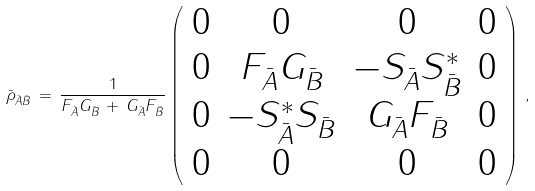Convert formula to latex. <formula><loc_0><loc_0><loc_500><loc_500>\bar { \rho } _ { \bar { A } \bar { B } } \, = \, \frac { 1 } { F _ { \bar { A } } G _ { \bar { B } } \, + \, G _ { \bar { A } } F _ { \bar { B } } } \left ( \begin{array} { c c c c } 0 & 0 & 0 & 0 \\ 0 & F _ { \bar { A } } G _ { \bar { B } } & - S _ { \bar { A } } S _ { \bar { B } } ^ { * } & 0 \\ 0 & - S _ { \bar { A } } ^ { * } S _ { \bar { B } } & G _ { \bar { A } } F _ { \bar { B } } & 0 \\ 0 & 0 & 0 & 0 \end{array} \right ) \, ,</formula> 